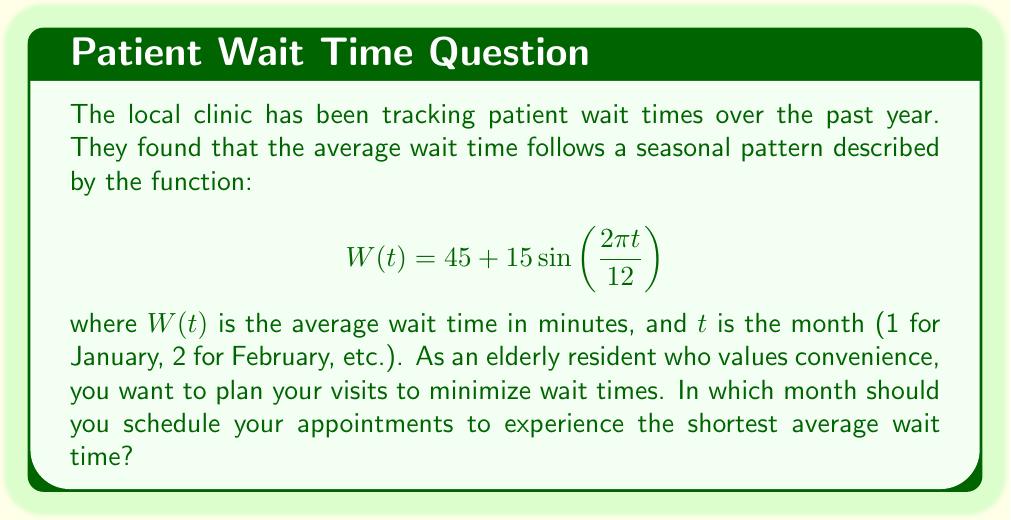Could you help me with this problem? To find the month with the shortest average wait time, we need to determine when the function $W(t)$ reaches its minimum value.

1) The sine function in $W(t)$ has a period of 12 months, matching the annual cycle.

2) The function $W(t)$ will be at its minimum when the sine term is at its minimum, which occurs when:

   $$\frac{2\pi t}{12} = \frac{3\pi}{2}$$

3) Solving for $t$:

   $$t = \frac{12 \cdot \frac{3\pi}{2}}{2\pi} = 9$$

4) This corresponds to the 9th month, which is September.

5) We can verify by calculating the wait times for adjacent months:

   August (t = 8):   $W(8) = 45 + 15\sin\left(\frac{4\pi}{3}\right) \approx 47.99$ minutes
   September (t = 9): $W(9) = 45 + 15\sin\left(\frac{3\pi}{2}\right) = 30$ minutes
   October (t = 10):  $W(10) = 45 + 15\sin\left(\frac{5\pi}{3}\right) \approx 32.01$ minutes

Therefore, September has the shortest average wait time of 30 minutes.
Answer: September 